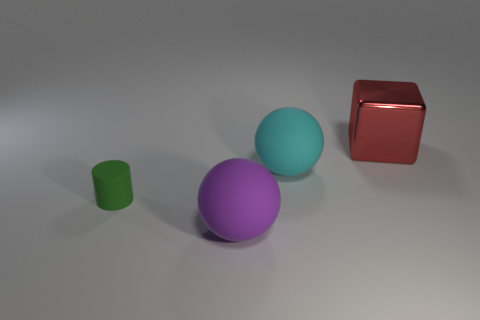How big is the object that is to the left of the large rubber sphere that is in front of the green thing?
Offer a terse response. Small. Is there a large red thing that has the same shape as the small object?
Give a very brief answer. No. There is a matte ball behind the tiny object; does it have the same size as the ball that is on the left side of the large cyan rubber thing?
Make the answer very short. Yes. Are there fewer big metal cubes that are behind the small object than big purple rubber spheres that are behind the purple thing?
Make the answer very short. No. What is the color of the big rubber object in front of the tiny thing?
Your answer should be very brief. Purple. Does the small rubber object have the same color as the big shiny thing?
Your answer should be very brief. No. How many cubes are to the left of the big matte sphere behind the object in front of the small cylinder?
Provide a succinct answer. 0. What size is the cyan matte sphere?
Make the answer very short. Large. There is a purple object that is the same size as the metallic block; what material is it?
Your answer should be very brief. Rubber. There is a red object; what number of cyan rubber things are behind it?
Offer a very short reply. 0. 